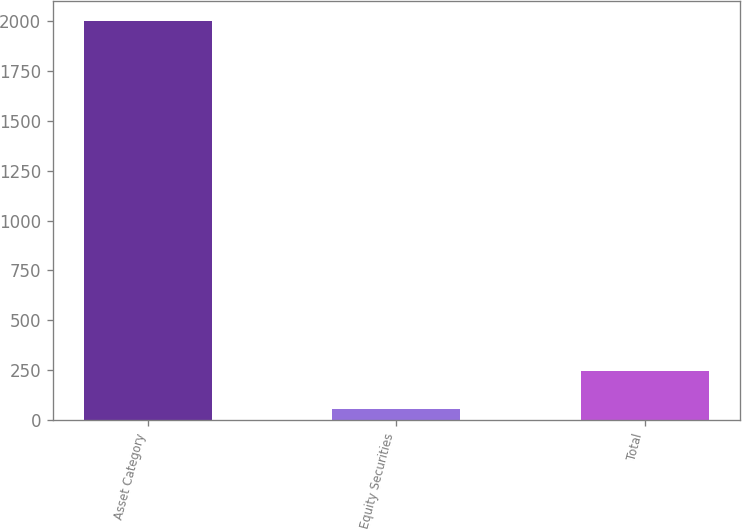<chart> <loc_0><loc_0><loc_500><loc_500><bar_chart><fcel>Asset Category<fcel>Equity Securities<fcel>Total<nl><fcel>2002<fcel>54<fcel>248.8<nl></chart> 